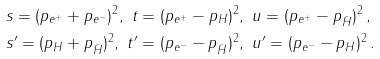Convert formula to latex. <formula><loc_0><loc_0><loc_500><loc_500>& s = ( p _ { e ^ { + } } + p _ { e ^ { - } } ) ^ { 2 } , \ t = ( p _ { e ^ { + } } - p _ { H } ) ^ { 2 } , \ u = ( p _ { e ^ { + } } - p _ { \bar { H } } ) ^ { 2 } \, , \\ & s ^ { \prime } = ( p _ { H } + p _ { \bar { H } } ) ^ { 2 } , \ t ^ { \prime } = ( p _ { e ^ { - } } - p _ { \bar { H } } ) ^ { 2 } , \ u ^ { \prime } = ( p _ { e ^ { - } } - p _ { H } ) ^ { 2 } \, .</formula> 